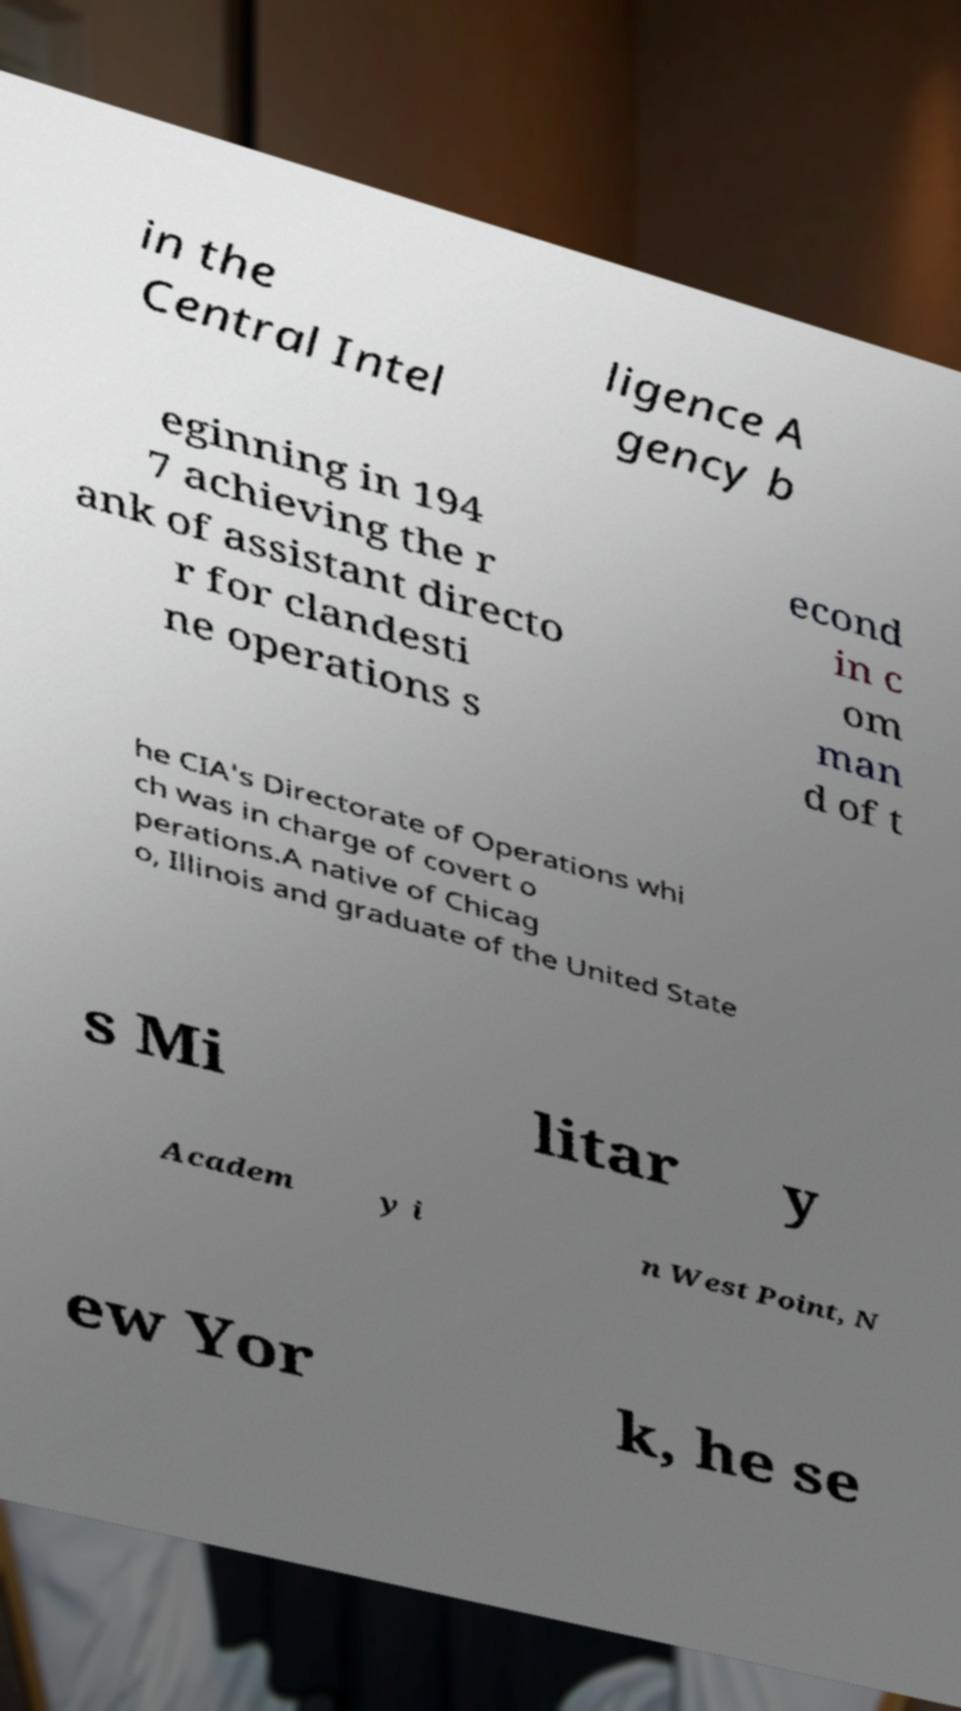Please identify and transcribe the text found in this image. in the Central Intel ligence A gency b eginning in 194 7 achieving the r ank of assistant directo r for clandesti ne operations s econd in c om man d of t he CIA's Directorate of Operations whi ch was in charge of covert o perations.A native of Chicag o, Illinois and graduate of the United State s Mi litar y Academ y i n West Point, N ew Yor k, he se 